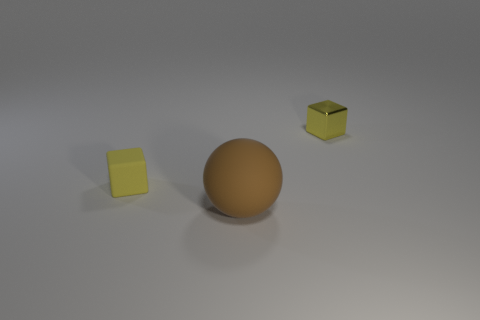Subtract all yellow balls. Subtract all green blocks. How many balls are left? 1 Subtract all purple balls. How many cyan cubes are left? 0 Add 3 tiny cyans. How many browns exist? 0 Subtract all tiny yellow rubber objects. Subtract all large red objects. How many objects are left? 2 Add 2 rubber cubes. How many rubber cubes are left? 3 Add 2 small green cubes. How many small green cubes exist? 2 Add 3 large green objects. How many objects exist? 6 Subtract 0 red spheres. How many objects are left? 3 How many yellow cubes must be subtracted to get 1 yellow cubes? 1 Subtract all blocks. How many objects are left? 1 